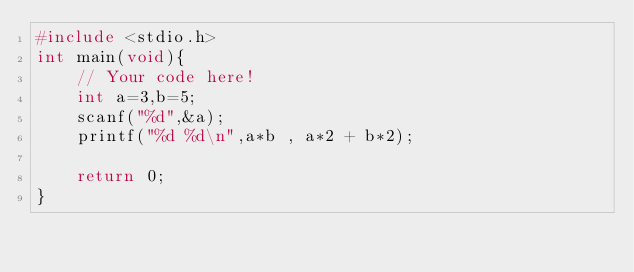Convert code to text. <code><loc_0><loc_0><loc_500><loc_500><_C_>#include <stdio.h>
int main(void){
    // Your code here!
    int a=3,b=5;
    scanf("%d",&a);
    printf("%d %d\n",a*b , a*2 + b*2);
    
    return 0;
}

</code> 